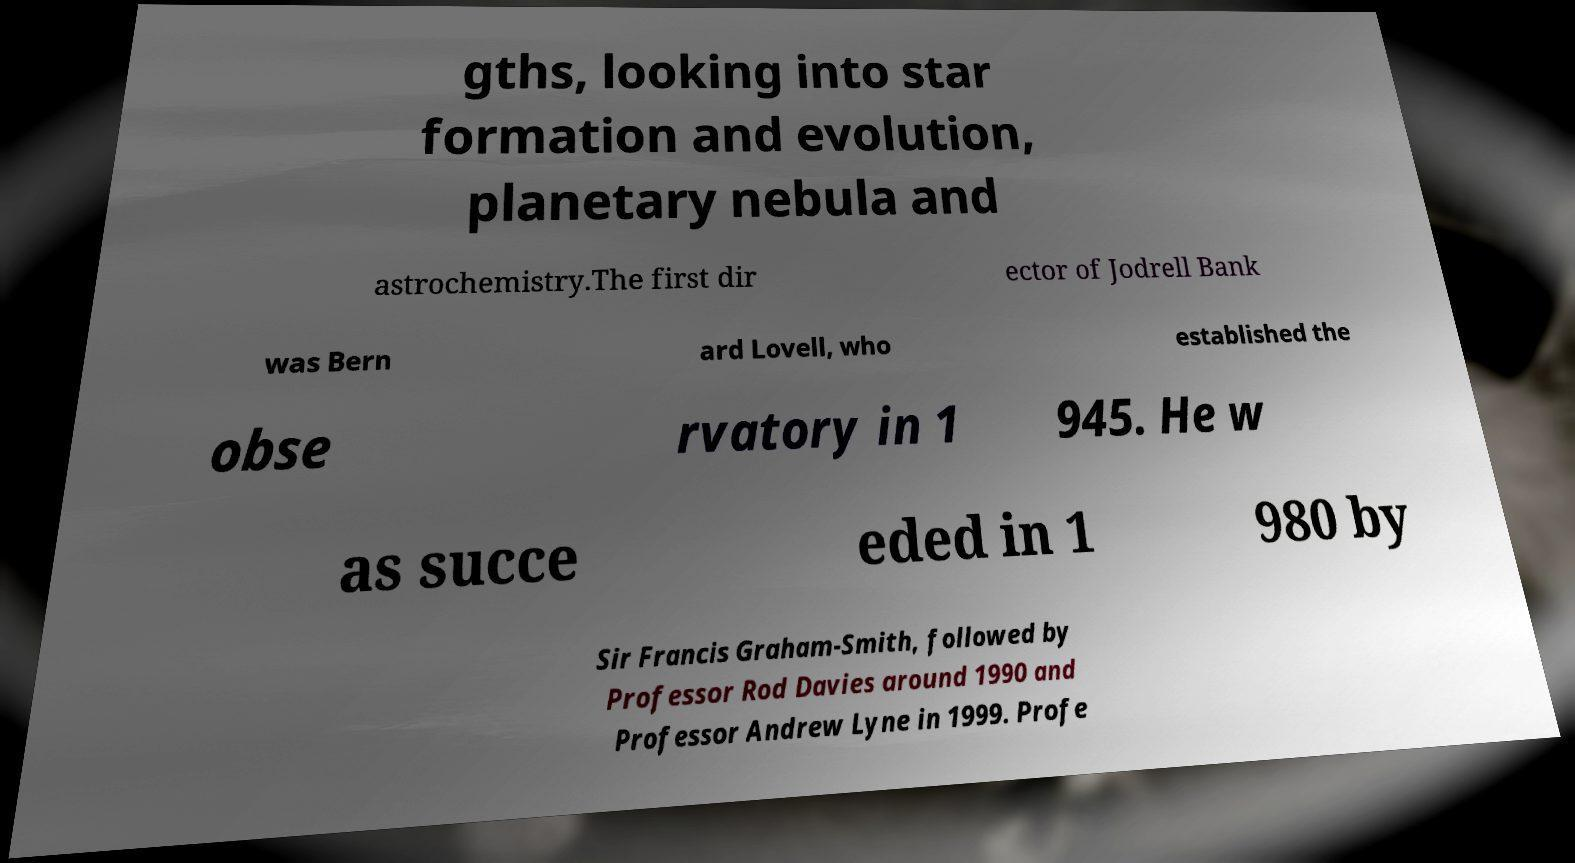For documentation purposes, I need the text within this image transcribed. Could you provide that? gths, looking into star formation and evolution, planetary nebula and astrochemistry.The first dir ector of Jodrell Bank was Bern ard Lovell, who established the obse rvatory in 1 945. He w as succe eded in 1 980 by Sir Francis Graham-Smith, followed by Professor Rod Davies around 1990 and Professor Andrew Lyne in 1999. Profe 